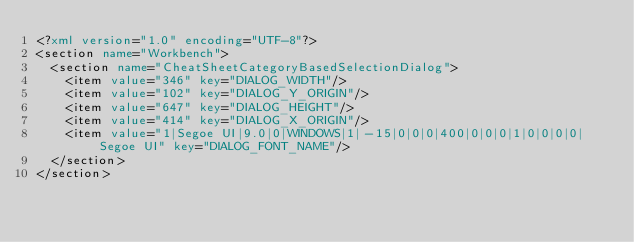Convert code to text. <code><loc_0><loc_0><loc_500><loc_500><_XML_><?xml version="1.0" encoding="UTF-8"?>
<section name="Workbench">
	<section name="CheatSheetCategoryBasedSelectionDialog">
		<item value="346" key="DIALOG_WIDTH"/>
		<item value="102" key="DIALOG_Y_ORIGIN"/>
		<item value="647" key="DIALOG_HEIGHT"/>
		<item value="414" key="DIALOG_X_ORIGIN"/>
		<item value="1|Segoe UI|9.0|0|WINDOWS|1|-15|0|0|0|400|0|0|0|1|0|0|0|0|Segoe UI" key="DIALOG_FONT_NAME"/>
	</section>
</section>
</code> 